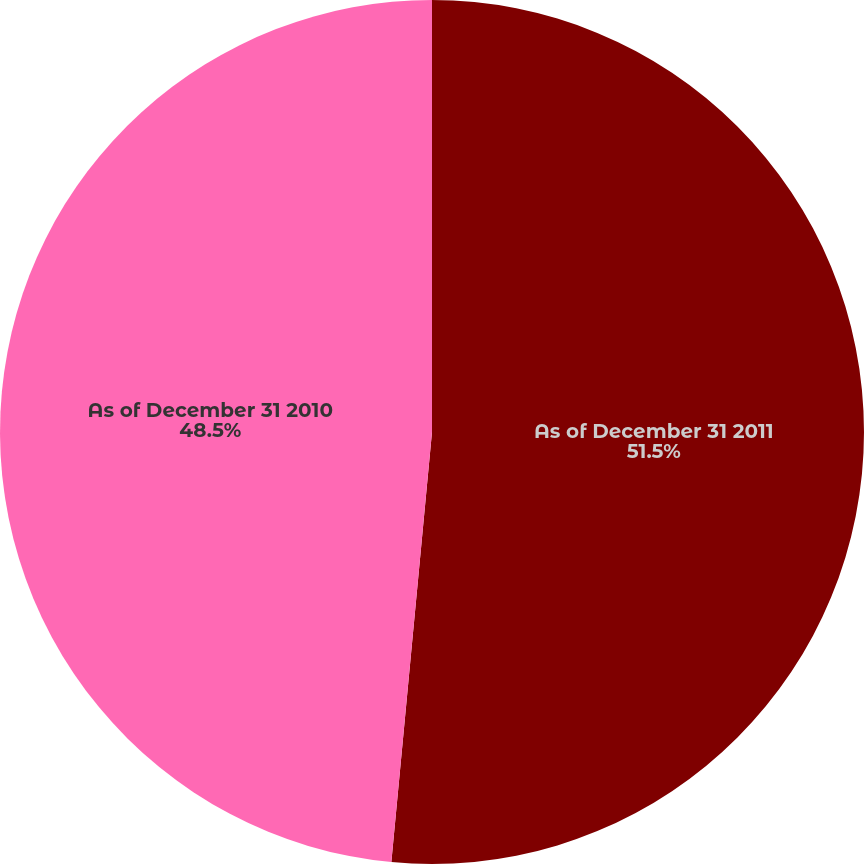Convert chart to OTSL. <chart><loc_0><loc_0><loc_500><loc_500><pie_chart><fcel>As of December 31 2011<fcel>As of December 31 2010<nl><fcel>51.5%<fcel>48.5%<nl></chart> 